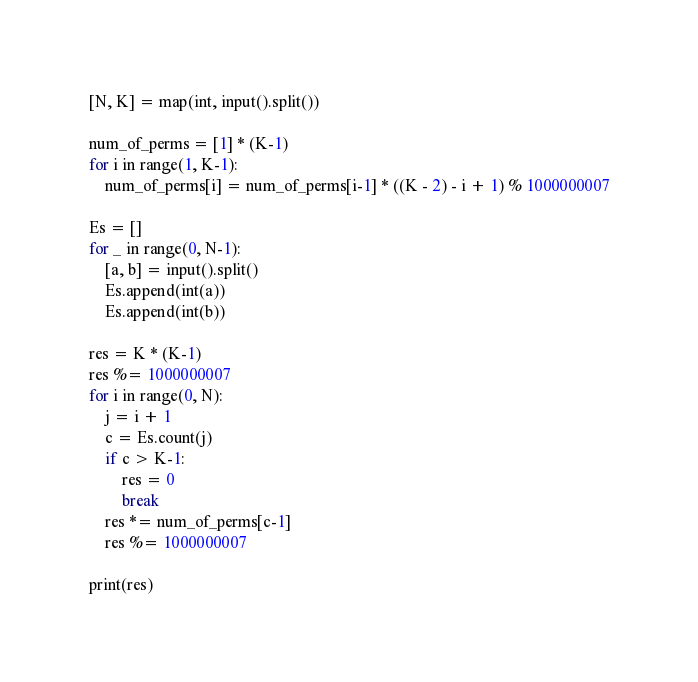<code> <loc_0><loc_0><loc_500><loc_500><_Python_>[N, K] = map(int, input().split())

num_of_perms = [1] * (K-1)
for i in range(1, K-1):
    num_of_perms[i] = num_of_perms[i-1] * ((K - 2) - i + 1) % 1000000007

Es = []
for _ in range(0, N-1):
    [a, b] = input().split()
    Es.append(int(a))
    Es.append(int(b))

res = K * (K-1)
res %= 1000000007
for i in range(0, N):
    j = i + 1
    c = Es.count(j)
    if c > K-1:
        res = 0
        break
    res *= num_of_perms[c-1]
    res %= 1000000007

print(res)
</code> 